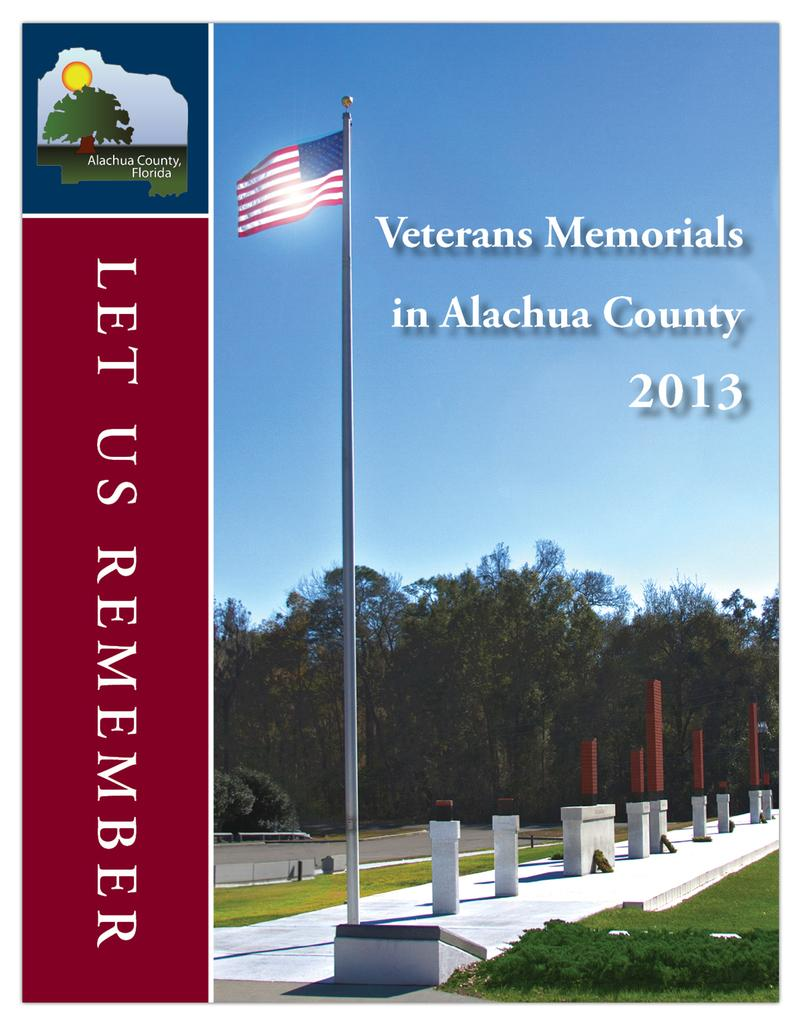What is the main subject of the image? There is a hoarding in the image. What can be seen on the hoarding? There is a pole, a flag, and text or writing on the image. What type of natural environment is visible in the image? There is grass, plants, trees, and sky visible in the image. What else can be seen in the image besides the hoarding? There are objects in the image. What type of brain is visible in the image? There is no brain visible in the image. What color is the underwear hanging on the pole in the image? There is no underwear present in the image. 